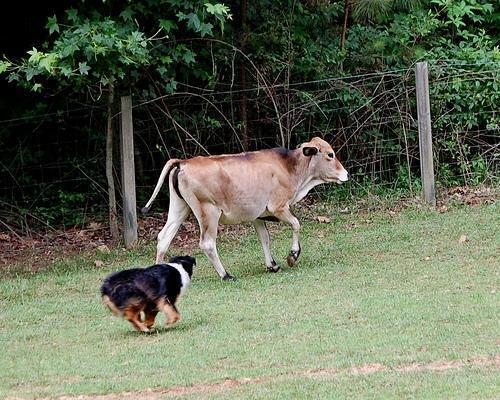How many cows can you see?
Give a very brief answer. 1. How many people can be seen?
Give a very brief answer. 0. 